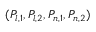Convert formula to latex. <formula><loc_0><loc_0><loc_500><loc_500>( P _ { l , 1 } , P _ { l , 2 } , P _ { n , 1 } , P _ { n , 2 } )</formula> 